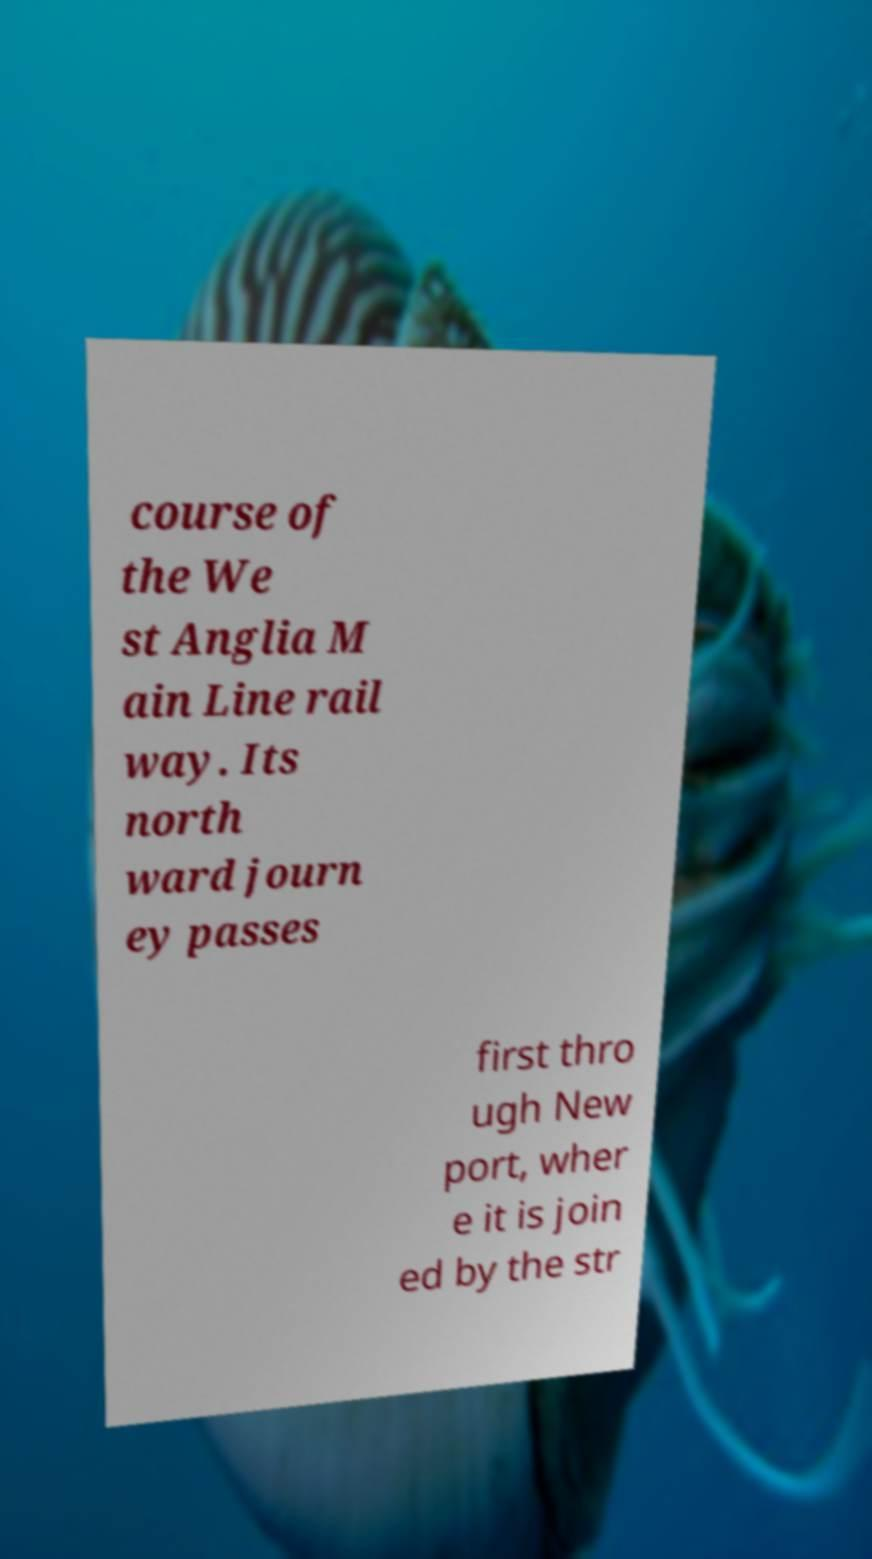Can you read and provide the text displayed in the image?This photo seems to have some interesting text. Can you extract and type it out for me? course of the We st Anglia M ain Line rail way. Its north ward journ ey passes first thro ugh New port, wher e it is join ed by the str 